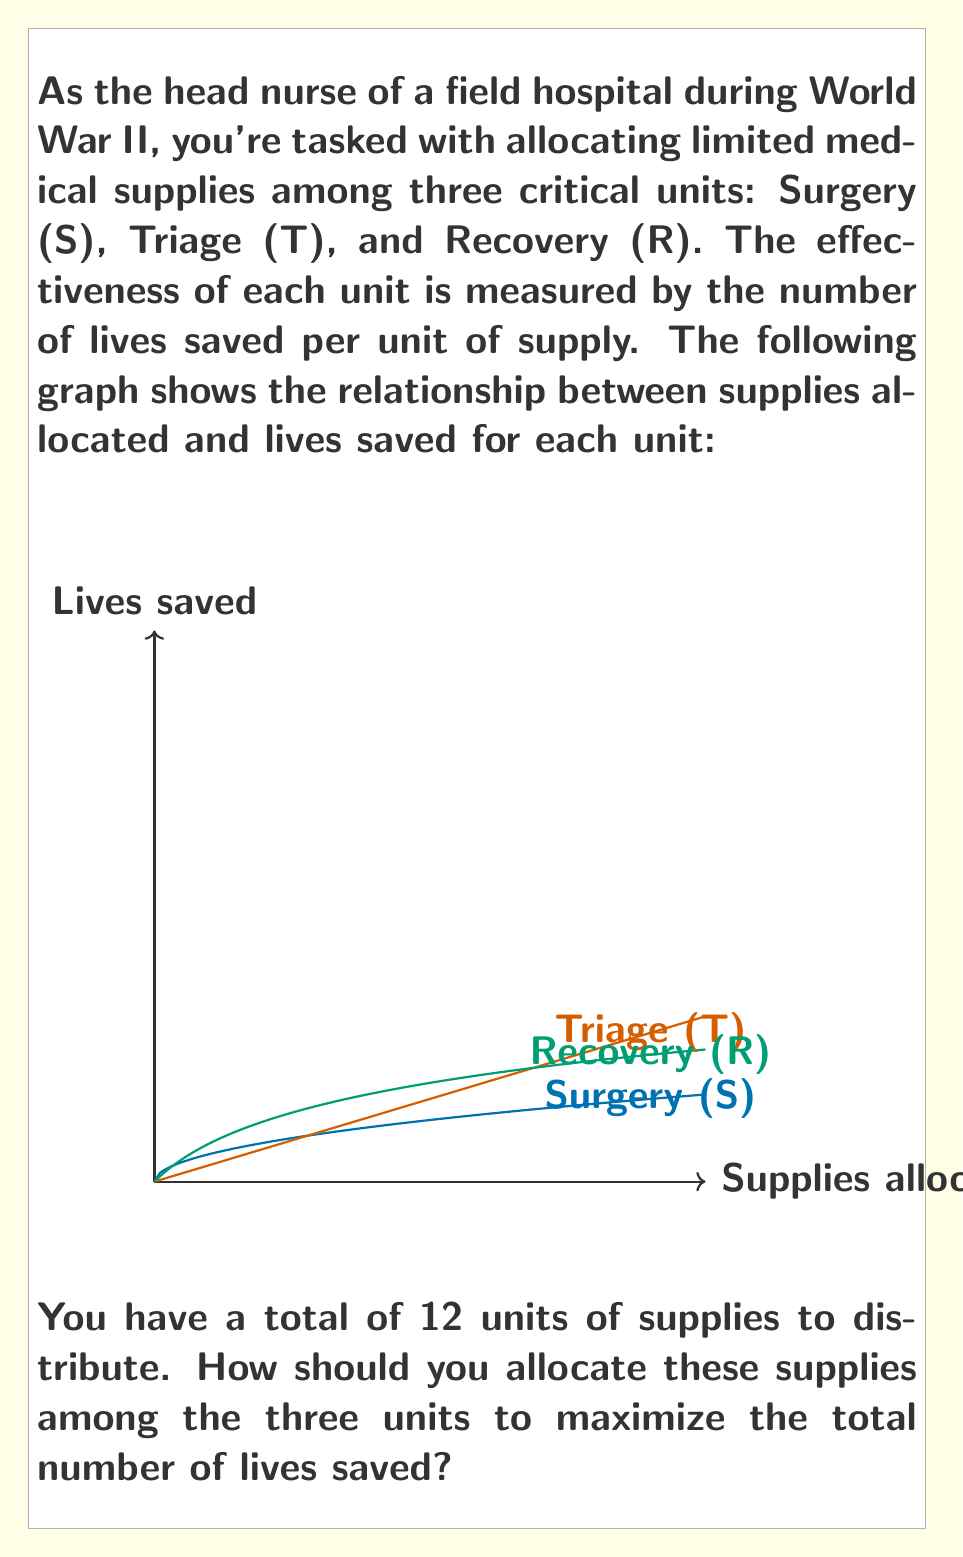Show me your answer to this math problem. To solve this problem, we'll use the principle of marginal analysis from decision theory. We need to allocate resources where they'll have the greatest marginal benefit.

Step 1: Determine the functions for lives saved in each unit.
Surgery (S): $f_S(x) = 5\sqrt{x}$
Triage (T): $f_T(x) = 3x$
Recovery (R): $f_R(x) = 10\log(x+1)$

Step 2: Calculate the marginal benefit (derivative) for each function.
$f'_S(x) = \frac{5}{2\sqrt{x}}$
$f'_T(x) = 3$
$f'_R(x) = \frac{10}{x+1}$

Step 3: Start allocating resources where the marginal benefit is highest.
Initially, Recovery has the highest marginal benefit: $f'_R(0) = 10$

Step 4: Continue allocating to Recovery until its marginal benefit drops below that of another unit.
At $x = 2.33$, $f'_R(2.33) = 3$, which equals Triage's constant marginal benefit.

Step 5: From this point, allocate equally between Recovery and Triage until their marginal benefit drops below Surgery's.
This occurs when Recovery and Triage each have 4 units (total 8 units allocated).

Step 6: Allocate the remaining 4 units equally among all three units.

Final allocation:
Surgery: 4 units
Triage: 5 units
Recovery: 3 units

Step 7: Calculate total lives saved:
$5\sqrt{4} + 3(5) + 10\log(3+1) = 10 + 15 + 13.86 = 38.86$
Answer: Surgery: 4, Triage: 5, Recovery: 3 